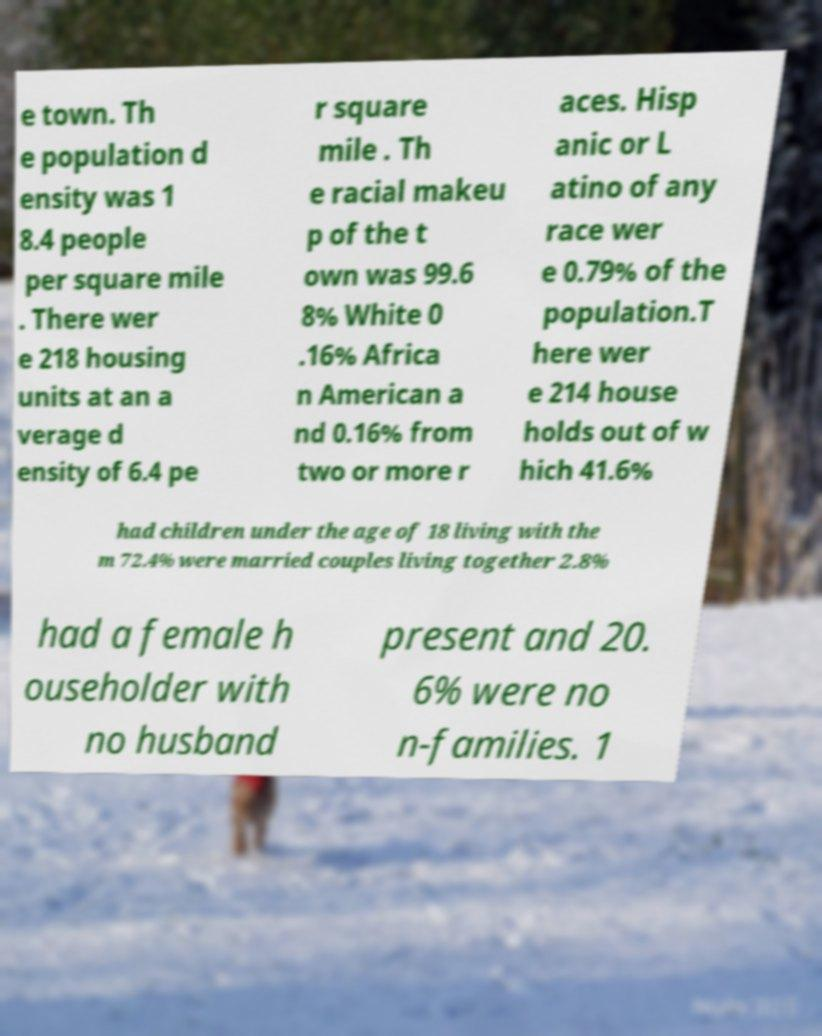Can you read and provide the text displayed in the image?This photo seems to have some interesting text. Can you extract and type it out for me? e town. Th e population d ensity was 1 8.4 people per square mile . There wer e 218 housing units at an a verage d ensity of 6.4 pe r square mile . Th e racial makeu p of the t own was 99.6 8% White 0 .16% Africa n American a nd 0.16% from two or more r aces. Hisp anic or L atino of any race wer e 0.79% of the population.T here wer e 214 house holds out of w hich 41.6% had children under the age of 18 living with the m 72.4% were married couples living together 2.8% had a female h ouseholder with no husband present and 20. 6% were no n-families. 1 